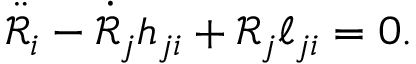<formula> <loc_0><loc_0><loc_500><loc_500>\ddot { \mathcal { R } } _ { i } - \dot { \mathcal { R } } _ { j } h _ { j i } + \mathcal { R } _ { j } \ell _ { j i } = 0 .</formula> 